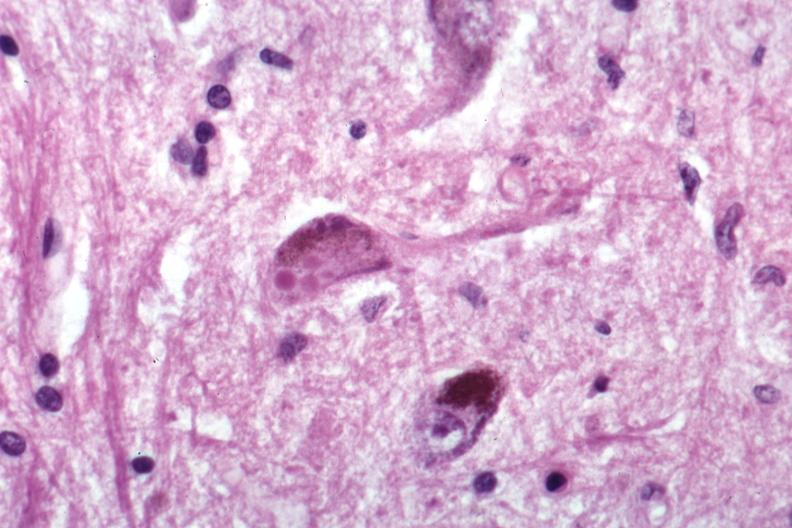s lewy body present?
Answer the question using a single word or phrase. Yes 